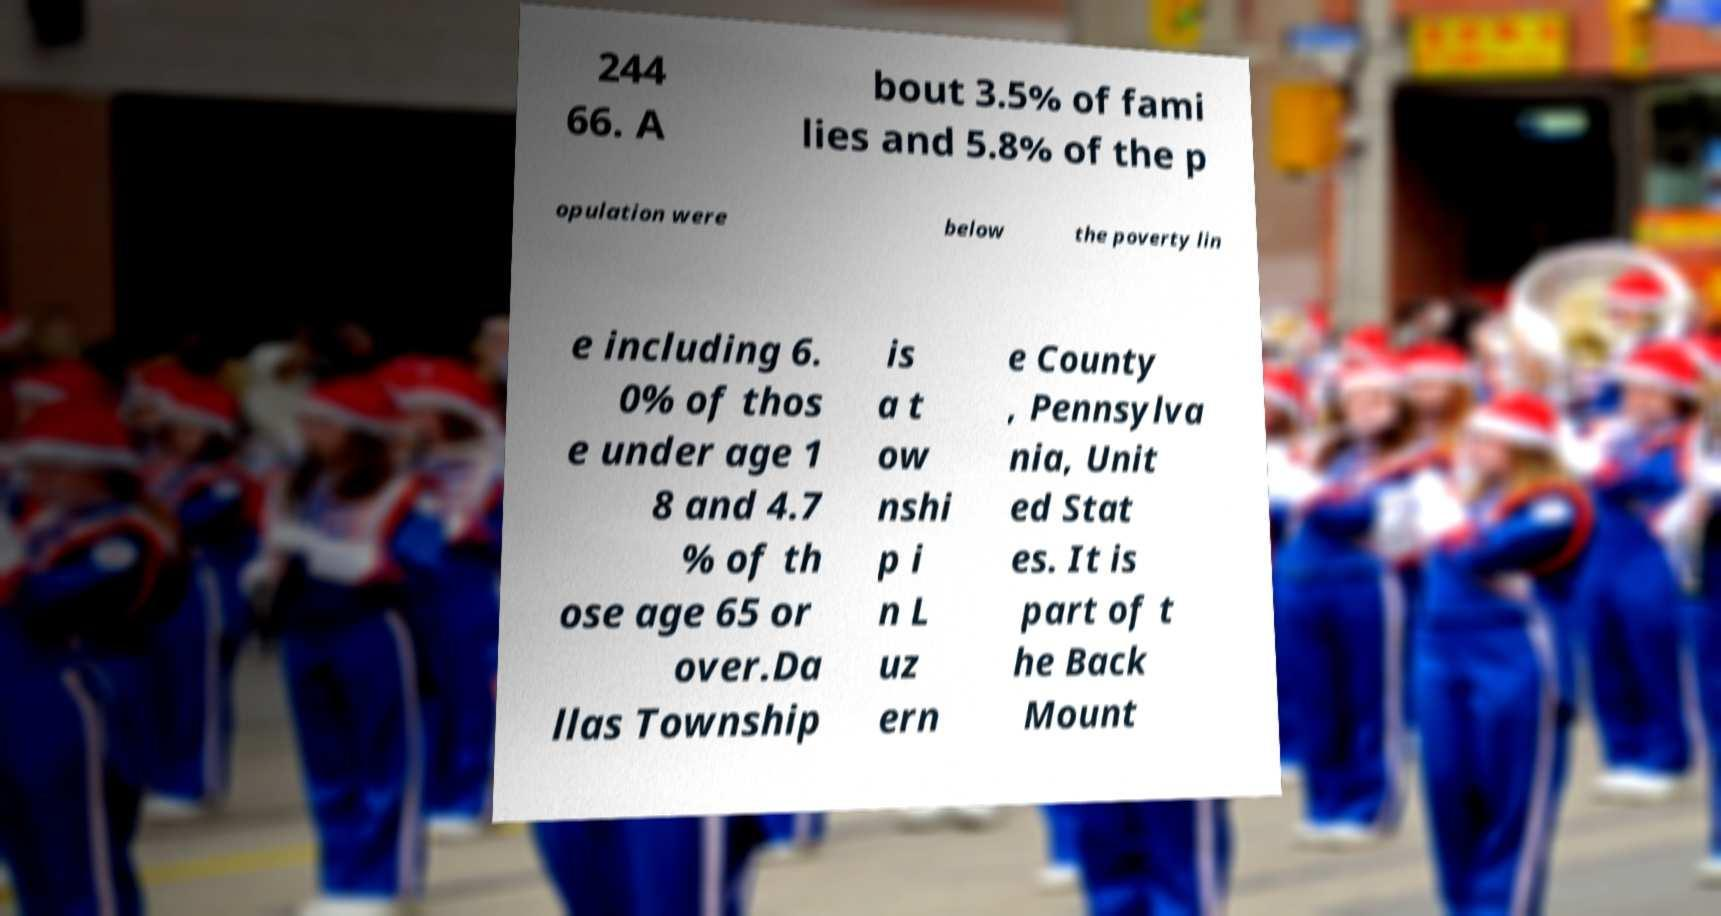Could you extract and type out the text from this image? 244 66. A bout 3.5% of fami lies and 5.8% of the p opulation were below the poverty lin e including 6. 0% of thos e under age 1 8 and 4.7 % of th ose age 65 or over.Da llas Township is a t ow nshi p i n L uz ern e County , Pennsylva nia, Unit ed Stat es. It is part of t he Back Mount 